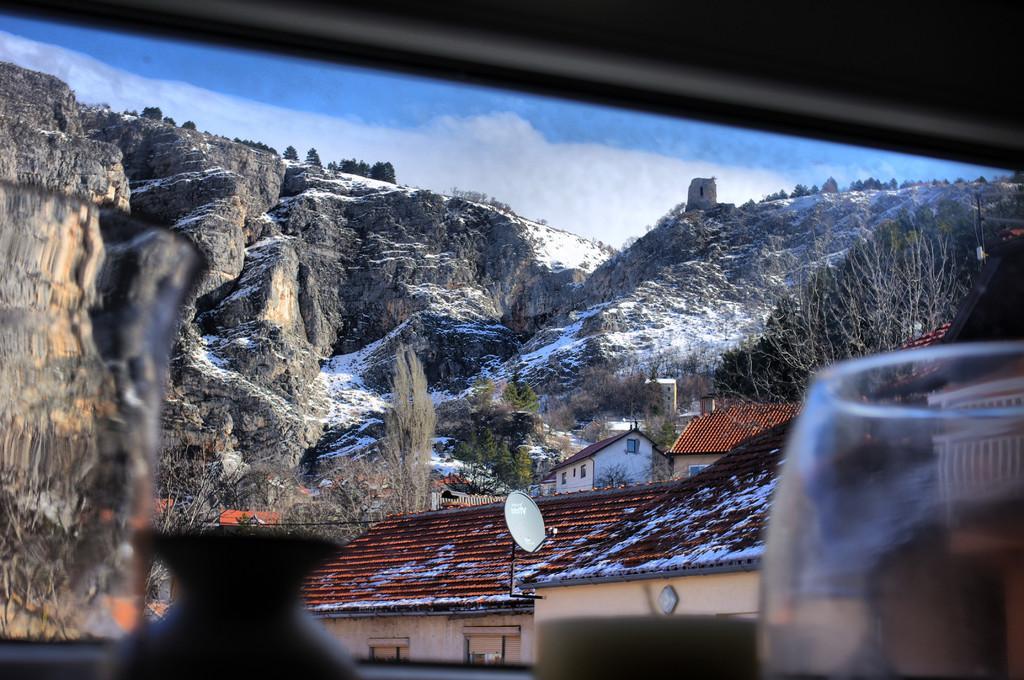Please provide a concise description of this image. This picture is consists a view from a window, which includes houses, trees, and mountains in the image. 